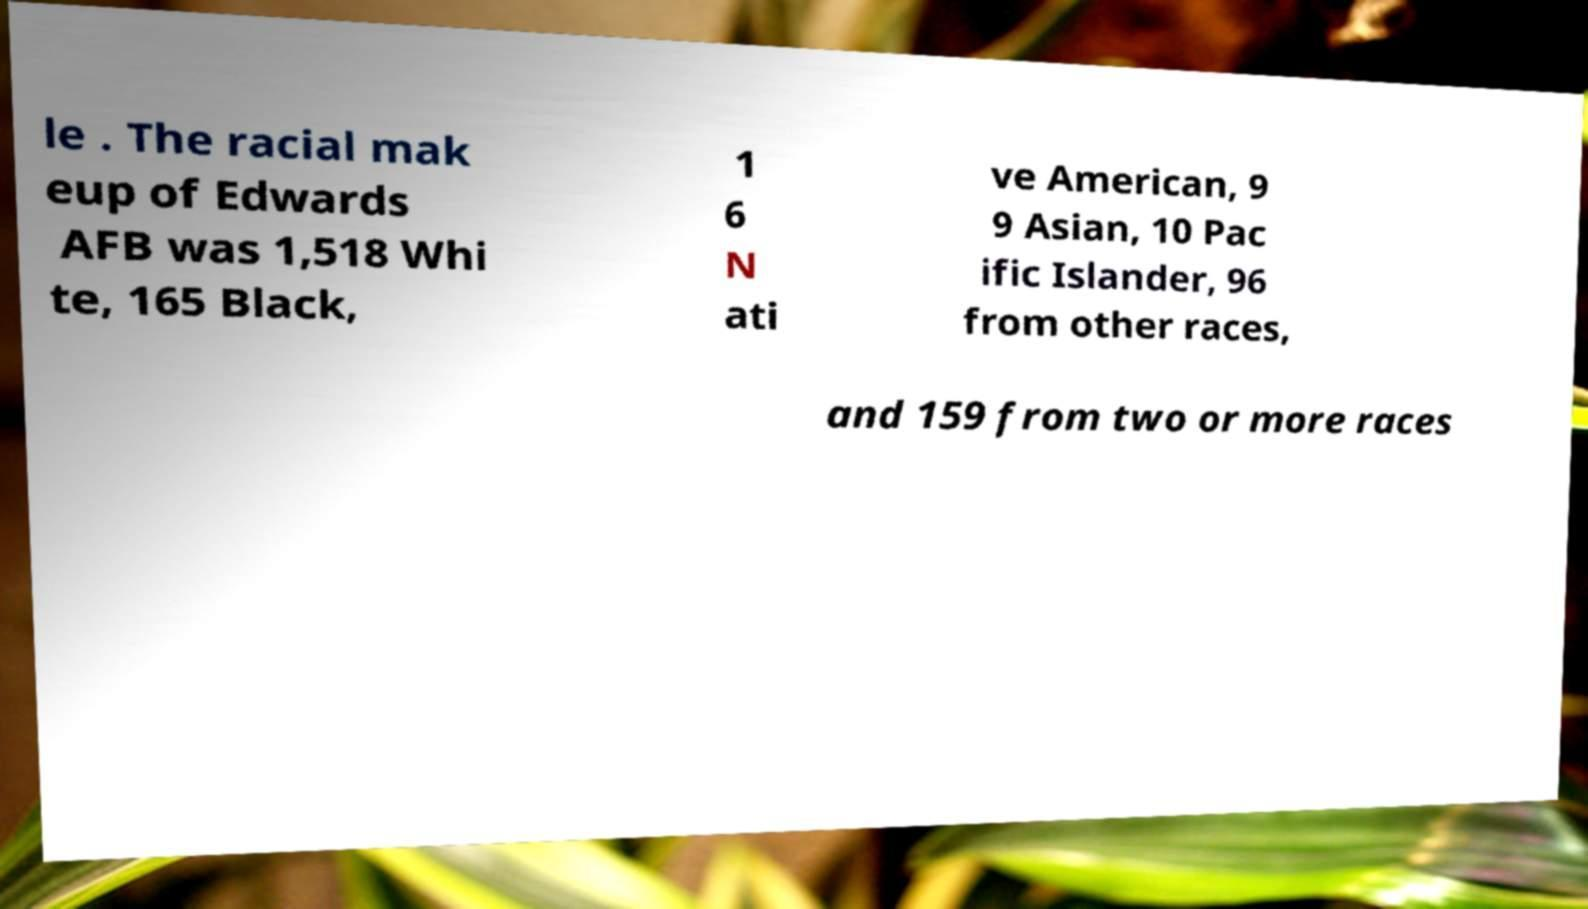There's text embedded in this image that I need extracted. Can you transcribe it verbatim? le . The racial mak eup of Edwards AFB was 1,518 Whi te, 165 Black, 1 6 N ati ve American, 9 9 Asian, 10 Pac ific Islander, 96 from other races, and 159 from two or more races 